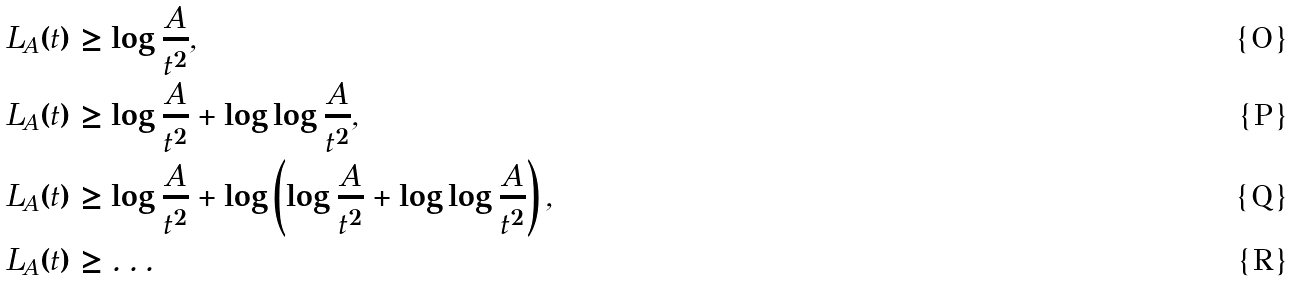<formula> <loc_0><loc_0><loc_500><loc_500>L _ { A } ( t ) & \geq \log \frac { A } { t ^ { 2 } } , \\ L _ { A } ( t ) & \geq \log \frac { A } { t ^ { 2 } } + \log \log \frac { A } { t ^ { 2 } } , \\ L _ { A } ( t ) & \geq \log \frac { A } { t ^ { 2 } } + \log \left ( \log \frac { A } { t ^ { 2 } } + \log \log \frac { A } { t ^ { 2 } } \right ) , \\ L _ { A } ( t ) & \geq \dots</formula> 